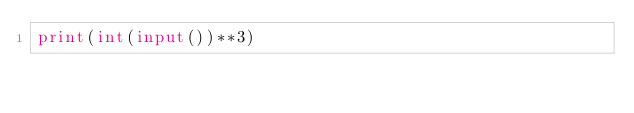Convert code to text. <code><loc_0><loc_0><loc_500><loc_500><_Python_>print(int(input())**3)</code> 